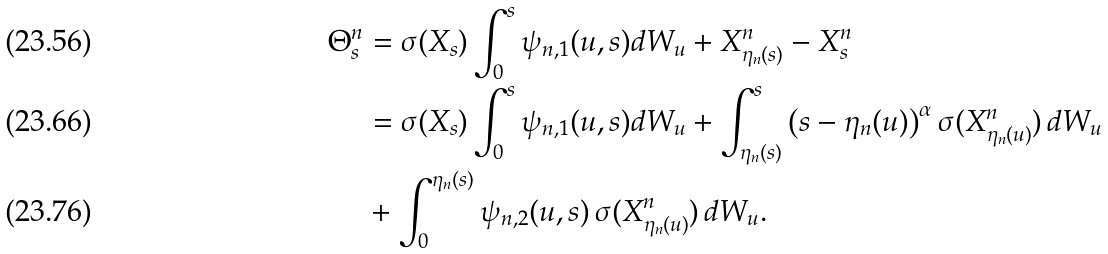<formula> <loc_0><loc_0><loc_500><loc_500>\Theta ^ { n } _ { s } & = \sigma ( X _ { s } ) \int _ { 0 } ^ { s } \psi _ { n , 1 } ( u , s ) d W _ { u } + X ^ { n } _ { \eta _ { n } ( s ) } - X ^ { n } _ { s } \\ & = \sigma ( X _ { s } ) \int _ { 0 } ^ { s } \psi _ { n , 1 } ( u , s ) d W _ { u } + \int ^ { s } _ { \eta _ { n } ( s ) } \left ( s - \eta _ { n } ( u ) \right ) ^ { \alpha } \sigma ( X ^ { n } _ { \eta _ { n } ( u ) } ) \, d W _ { u } \\ & + \int ^ { \eta _ { n } ( s ) } _ { 0 } \psi _ { n , 2 } ( u , s ) \, \sigma ( X ^ { n } _ { \eta _ { n } ( u ) } ) \, d W _ { u } .</formula> 